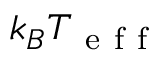Convert formula to latex. <formula><loc_0><loc_0><loc_500><loc_500>k _ { B } T _ { e f f }</formula> 